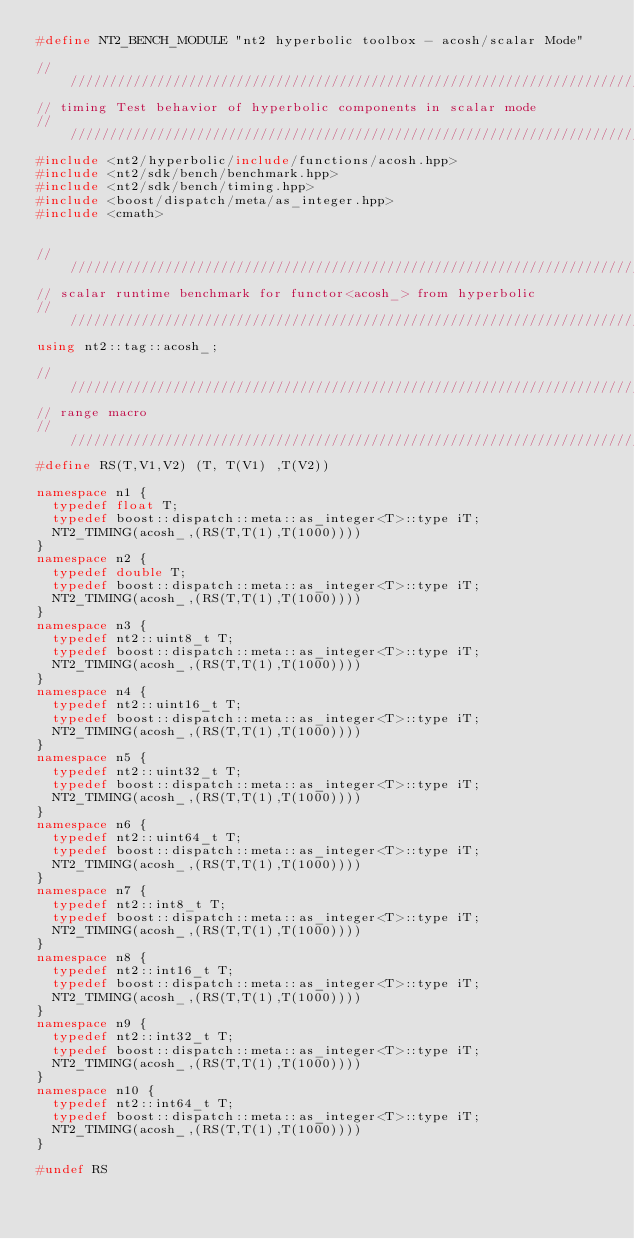<code> <loc_0><loc_0><loc_500><loc_500><_C++_>#define NT2_BENCH_MODULE "nt2 hyperbolic toolbox - acosh/scalar Mode"

//////////////////////////////////////////////////////////////////////////////
// timing Test behavior of hyperbolic components in scalar mode
//////////////////////////////////////////////////////////////////////////////
#include <nt2/hyperbolic/include/functions/acosh.hpp>
#include <nt2/sdk/bench/benchmark.hpp>
#include <nt2/sdk/bench/timing.hpp>
#include <boost/dispatch/meta/as_integer.hpp>
#include <cmath>


//////////////////////////////////////////////////////////////////////////////
// scalar runtime benchmark for functor<acosh_> from hyperbolic
//////////////////////////////////////////////////////////////////////////////
using nt2::tag::acosh_;

//////////////////////////////////////////////////////////////////////////////
// range macro
//////////////////////////////////////////////////////////////////////////////
#define RS(T,V1,V2) (T, T(V1) ,T(V2))

namespace n1 {
  typedef float T;
  typedef boost::dispatch::meta::as_integer<T>::type iT;
  NT2_TIMING(acosh_,(RS(T,T(1),T(1000))))
}
namespace n2 {
  typedef double T;
  typedef boost::dispatch::meta::as_integer<T>::type iT;
  NT2_TIMING(acosh_,(RS(T,T(1),T(1000))))
}
namespace n3 {
  typedef nt2::uint8_t T;
  typedef boost::dispatch::meta::as_integer<T>::type iT;
  NT2_TIMING(acosh_,(RS(T,T(1),T(1000))))
}
namespace n4 {
  typedef nt2::uint16_t T;
  typedef boost::dispatch::meta::as_integer<T>::type iT;
  NT2_TIMING(acosh_,(RS(T,T(1),T(1000))))
}
namespace n5 {
  typedef nt2::uint32_t T;
  typedef boost::dispatch::meta::as_integer<T>::type iT;
  NT2_TIMING(acosh_,(RS(T,T(1),T(1000))))
}
namespace n6 {
  typedef nt2::uint64_t T;
  typedef boost::dispatch::meta::as_integer<T>::type iT;
  NT2_TIMING(acosh_,(RS(T,T(1),T(1000))))
}
namespace n7 {
  typedef nt2::int8_t T;
  typedef boost::dispatch::meta::as_integer<T>::type iT;
  NT2_TIMING(acosh_,(RS(T,T(1),T(1000))))
}
namespace n8 {
  typedef nt2::int16_t T;
  typedef boost::dispatch::meta::as_integer<T>::type iT;
  NT2_TIMING(acosh_,(RS(T,T(1),T(1000))))
}
namespace n9 {
  typedef nt2::int32_t T;
  typedef boost::dispatch::meta::as_integer<T>::type iT;
  NT2_TIMING(acosh_,(RS(T,T(1),T(1000))))
}
namespace n10 {
  typedef nt2::int64_t T;
  typedef boost::dispatch::meta::as_integer<T>::type iT;
  NT2_TIMING(acosh_,(RS(T,T(1),T(1000))))
}

#undef RS
</code> 